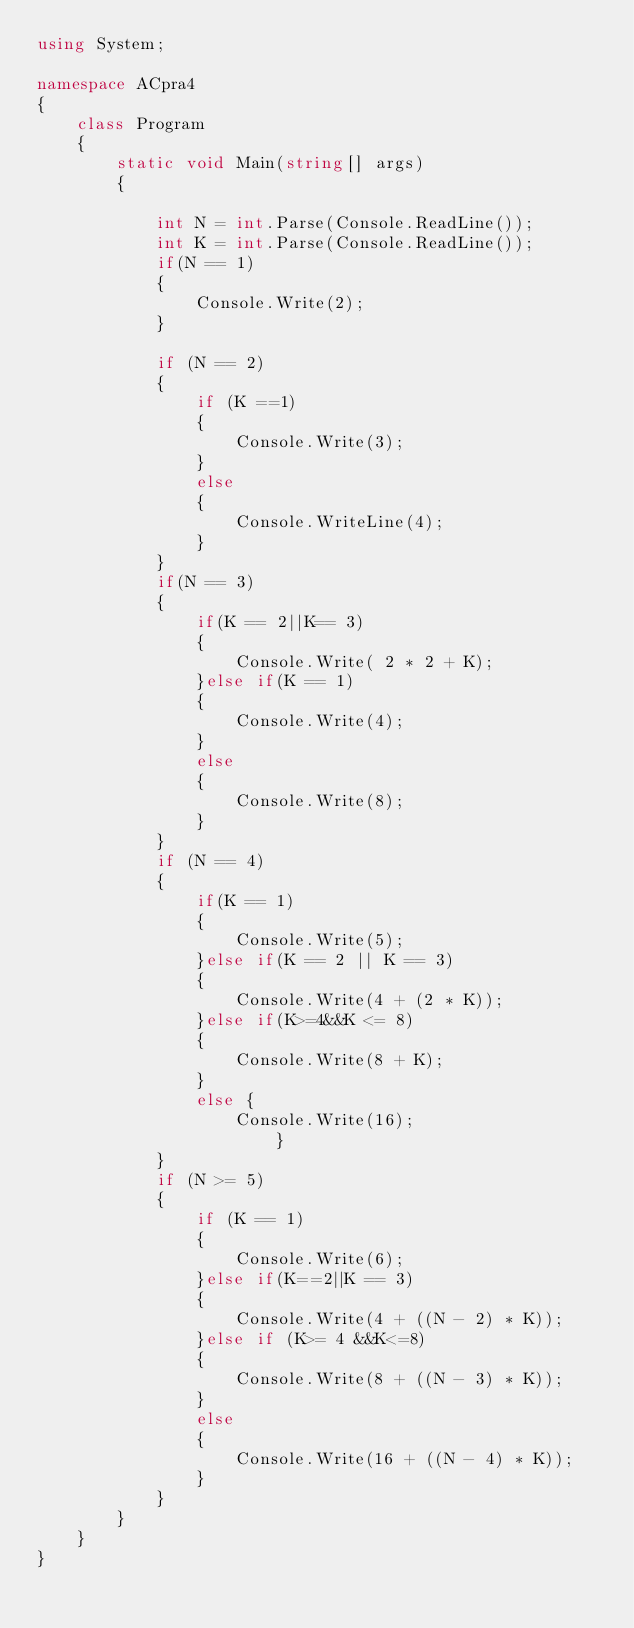Convert code to text. <code><loc_0><loc_0><loc_500><loc_500><_C#_>using System;

namespace ACpra4
{
    class Program
    {
        static void Main(string[] args)
        {

            int N = int.Parse(Console.ReadLine());
            int K = int.Parse(Console.ReadLine());
            if(N == 1)
            {
                Console.Write(2);   
            }

            if (N == 2)
            {
                if (K ==1)
                {
                    Console.Write(3);
                }
                else
                {
                    Console.WriteLine(4);
                }
            }
            if(N == 3)
            {
                if(K == 2||K== 3)
                {
                    Console.Write( 2 * 2 + K);
                }else if(K == 1)
                {
                    Console.Write(4);
                }
                else
                {
                    Console.Write(8);
                }
            }
            if (N == 4)
            {
                if(K == 1)
                {
                    Console.Write(5);
                }else if(K == 2 || K == 3)
                {
                    Console.Write(4 + (2 * K));
                }else if(K>=4&&K <= 8)
                {
                    Console.Write(8 + K);
                }
                else {
                    Console.Write(16);
                        }
            }
            if (N >= 5)
            {
                if (K == 1)
                {
                    Console.Write(6);
                }else if(K==2||K == 3)
                {
                    Console.Write(4 + ((N - 2) * K));
                }else if (K>= 4 &&K<=8)
                {
                    Console.Write(8 + ((N - 3) * K));
                }
                else
                {
                    Console.Write(16 + ((N - 4) * K));
                }
            }
        }
    }
}
</code> 